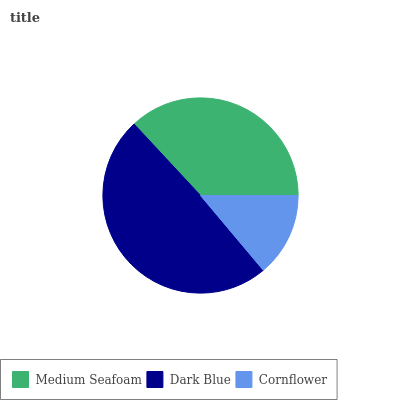Is Cornflower the minimum?
Answer yes or no. Yes. Is Dark Blue the maximum?
Answer yes or no. Yes. Is Dark Blue the minimum?
Answer yes or no. No. Is Cornflower the maximum?
Answer yes or no. No. Is Dark Blue greater than Cornflower?
Answer yes or no. Yes. Is Cornflower less than Dark Blue?
Answer yes or no. Yes. Is Cornflower greater than Dark Blue?
Answer yes or no. No. Is Dark Blue less than Cornflower?
Answer yes or no. No. Is Medium Seafoam the high median?
Answer yes or no. Yes. Is Medium Seafoam the low median?
Answer yes or no. Yes. Is Dark Blue the high median?
Answer yes or no. No. Is Dark Blue the low median?
Answer yes or no. No. 